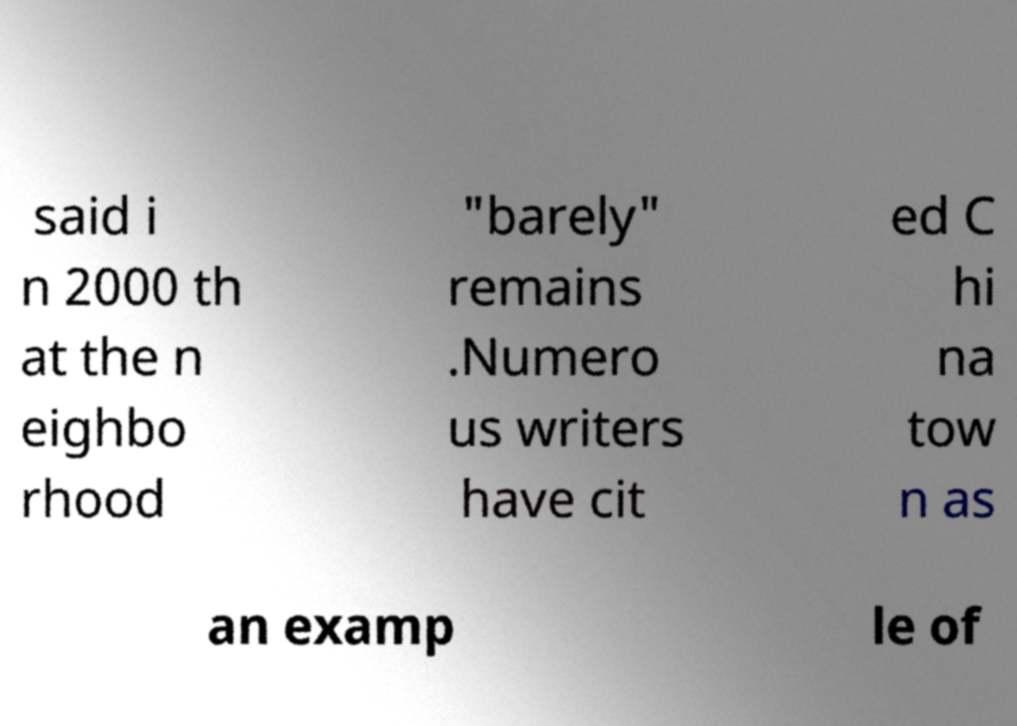Can you accurately transcribe the text from the provided image for me? said i n 2000 th at the n eighbo rhood "barely" remains .Numero us writers have cit ed C hi na tow n as an examp le of 